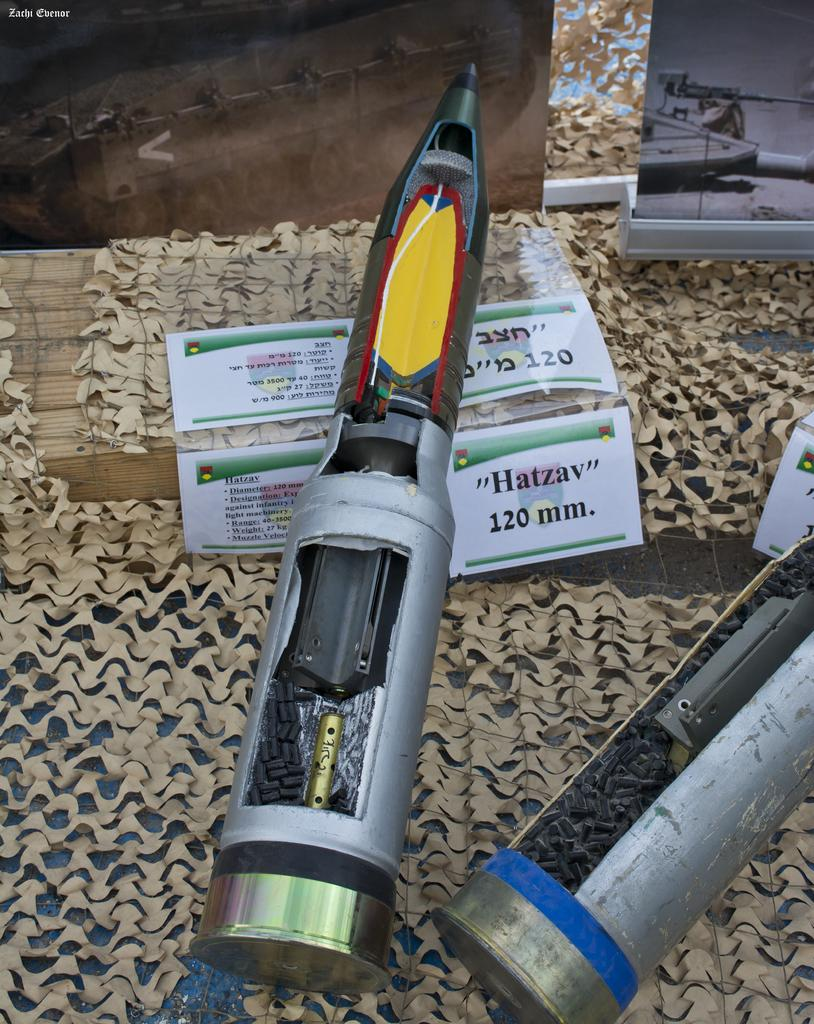What objects are in the foreground of the image? There are two devices that resemble guns in the foreground of the image. What can be seen on the floor in the image? There is a floor visible in the image, and there are papers on the floor. What is located in the background of the image? There are two boards in the background of the image. What type of match is being played in the image? There is no match being played in the image; it does not depict any sports or games. What industry is represented by the objects in the image? The image does not represent any specific industry; it simply shows two devices that resemble guns, papers on the floor, and two boards in the background. 